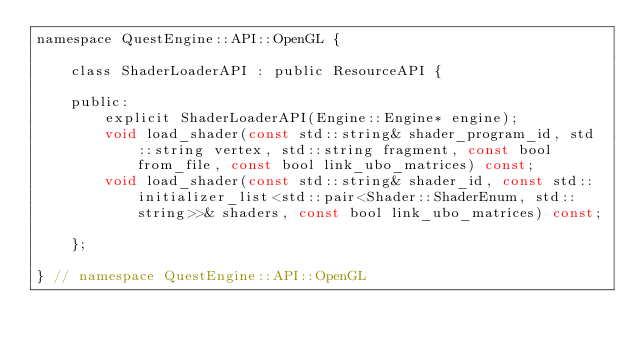<code> <loc_0><loc_0><loc_500><loc_500><_C_>namespace QuestEngine::API::OpenGL {

	class ShaderLoaderAPI : public ResourceAPI {

	public:
		explicit ShaderLoaderAPI(Engine::Engine* engine);
		void load_shader(const std::string& shader_program_id, std::string vertex, std::string fragment, const bool from_file, const bool link_ubo_matrices) const;
		void load_shader(const std::string& shader_id, const std::initializer_list<std::pair<Shader::ShaderEnum, std::string>>& shaders, const bool link_ubo_matrices) const;

	};

} // namespace QuestEngine::API::OpenGL</code> 